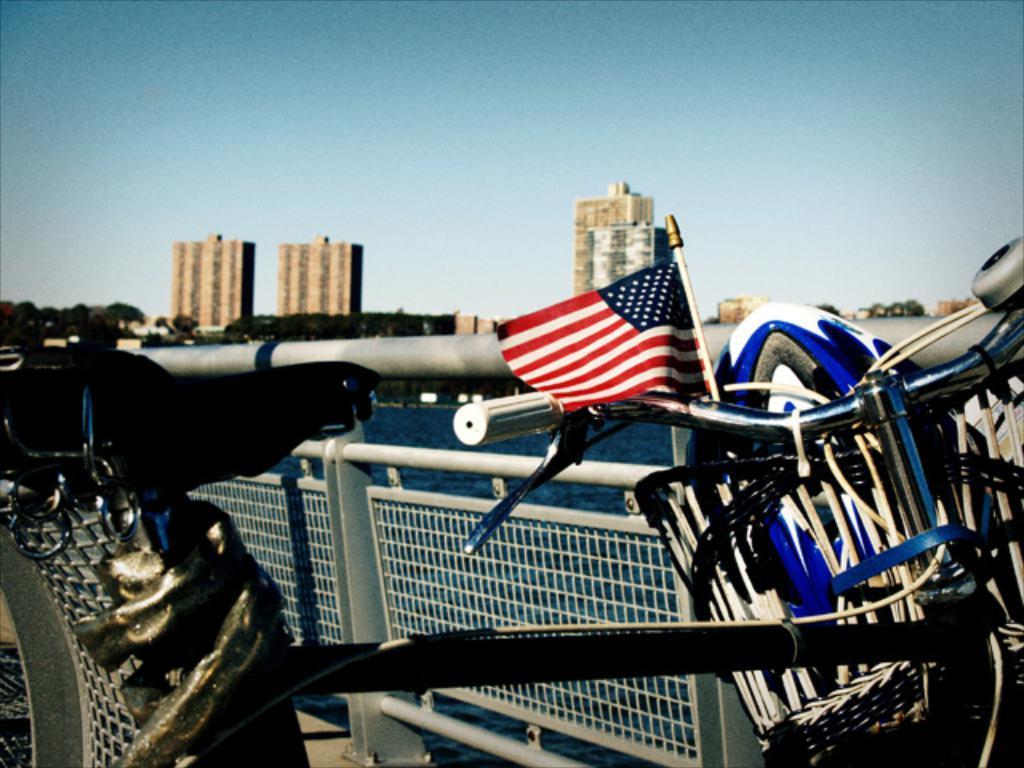In one or two sentences, can you explain what this image depicts? In this picture I can see a bicycle, a flag and a helmet in a basket , and there are iron grills, water , trees, buildings, and in the background there is sky. 